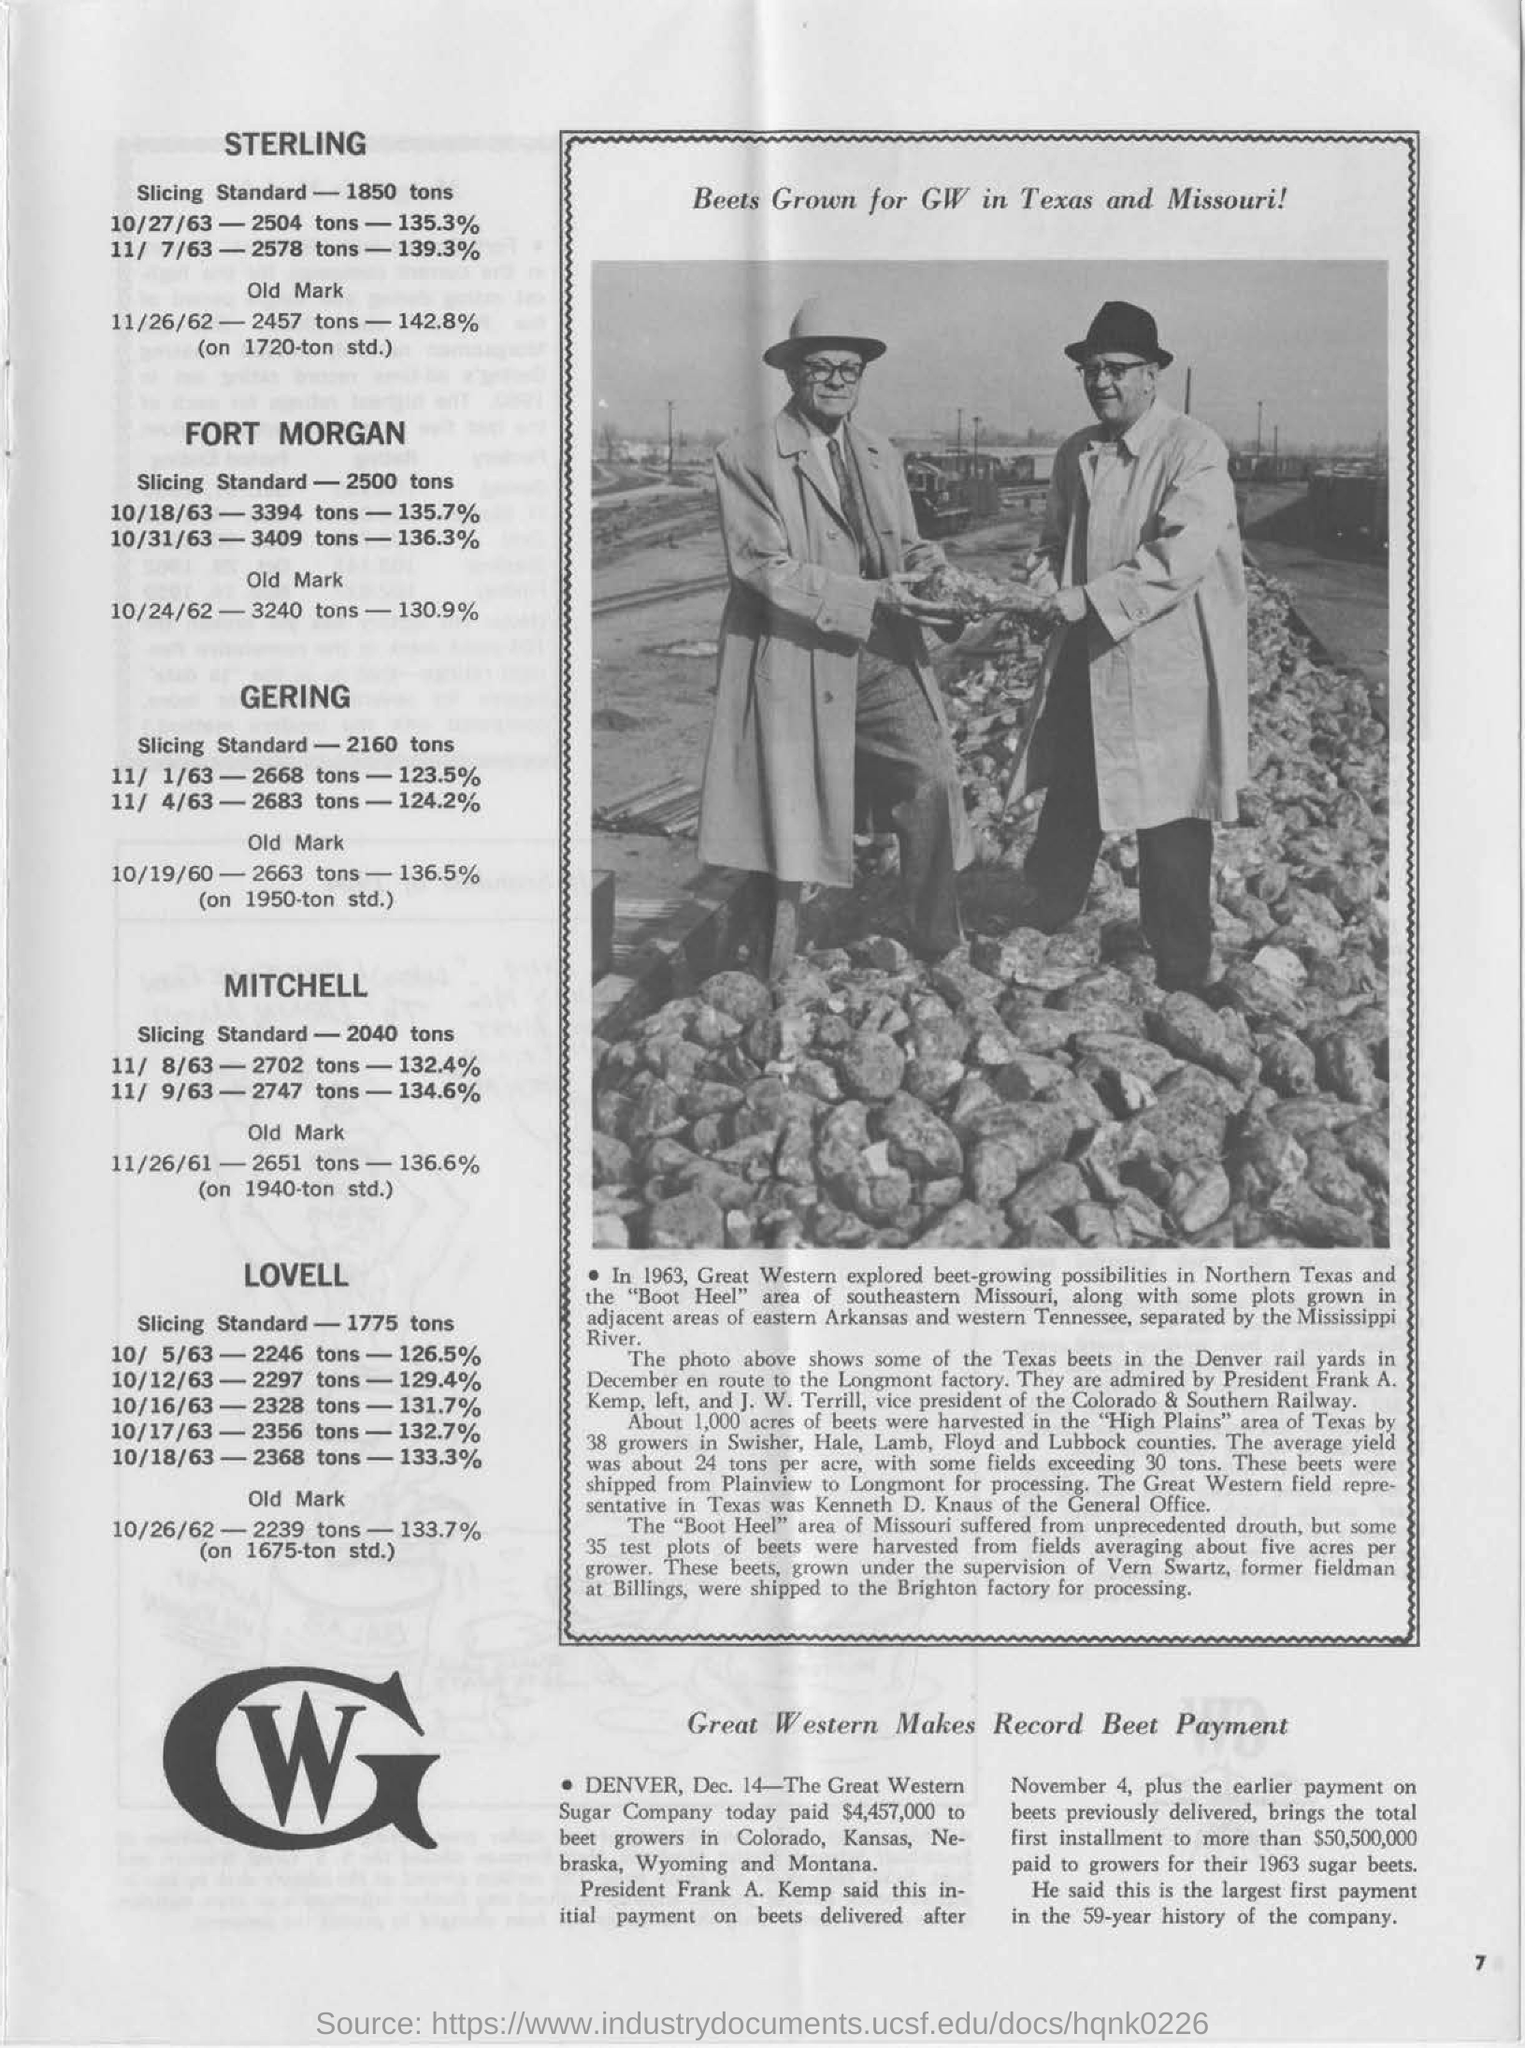What are the names of the people in the photo?
Ensure brevity in your answer.  Frank A. Kemp, left, and J. W. Terrill. Who is j. w. terrill?
Make the answer very short. Vice president of the colorado & southern railway. Who is frank a. kemp?
Offer a terse response. President. What is the slicing standard of "sterling"?
Your answer should be compact. 1850 tons. What is the slicing standard of "gering"?
Make the answer very short. 2160 tons. 